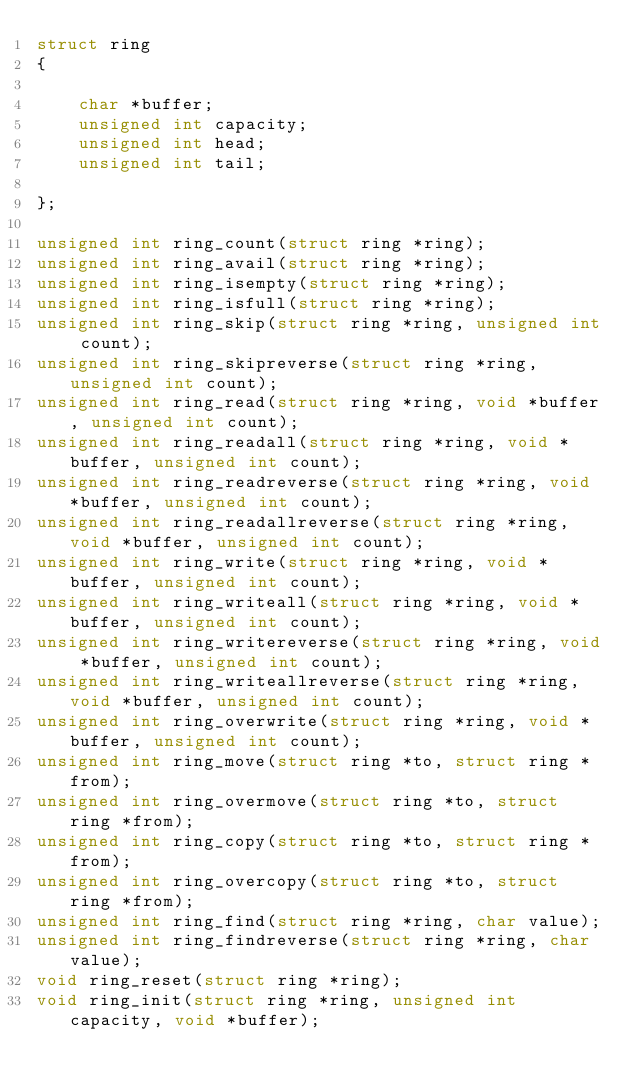Convert code to text. <code><loc_0><loc_0><loc_500><loc_500><_C_>struct ring
{

    char *buffer;
    unsigned int capacity;
    unsigned int head;
    unsigned int tail;

};

unsigned int ring_count(struct ring *ring);
unsigned int ring_avail(struct ring *ring);
unsigned int ring_isempty(struct ring *ring);
unsigned int ring_isfull(struct ring *ring);
unsigned int ring_skip(struct ring *ring, unsigned int count);
unsigned int ring_skipreverse(struct ring *ring, unsigned int count);
unsigned int ring_read(struct ring *ring, void *buffer, unsigned int count);
unsigned int ring_readall(struct ring *ring, void *buffer, unsigned int count);
unsigned int ring_readreverse(struct ring *ring, void *buffer, unsigned int count);
unsigned int ring_readallreverse(struct ring *ring, void *buffer, unsigned int count);
unsigned int ring_write(struct ring *ring, void *buffer, unsigned int count);
unsigned int ring_writeall(struct ring *ring, void *buffer, unsigned int count);
unsigned int ring_writereverse(struct ring *ring, void *buffer, unsigned int count);
unsigned int ring_writeallreverse(struct ring *ring, void *buffer, unsigned int count);
unsigned int ring_overwrite(struct ring *ring, void *buffer, unsigned int count);
unsigned int ring_move(struct ring *to, struct ring *from);
unsigned int ring_overmove(struct ring *to, struct ring *from);
unsigned int ring_copy(struct ring *to, struct ring *from);
unsigned int ring_overcopy(struct ring *to, struct ring *from);
unsigned int ring_find(struct ring *ring, char value);
unsigned int ring_findreverse(struct ring *ring, char value);
void ring_reset(struct ring *ring);
void ring_init(struct ring *ring, unsigned int capacity, void *buffer);
</code> 